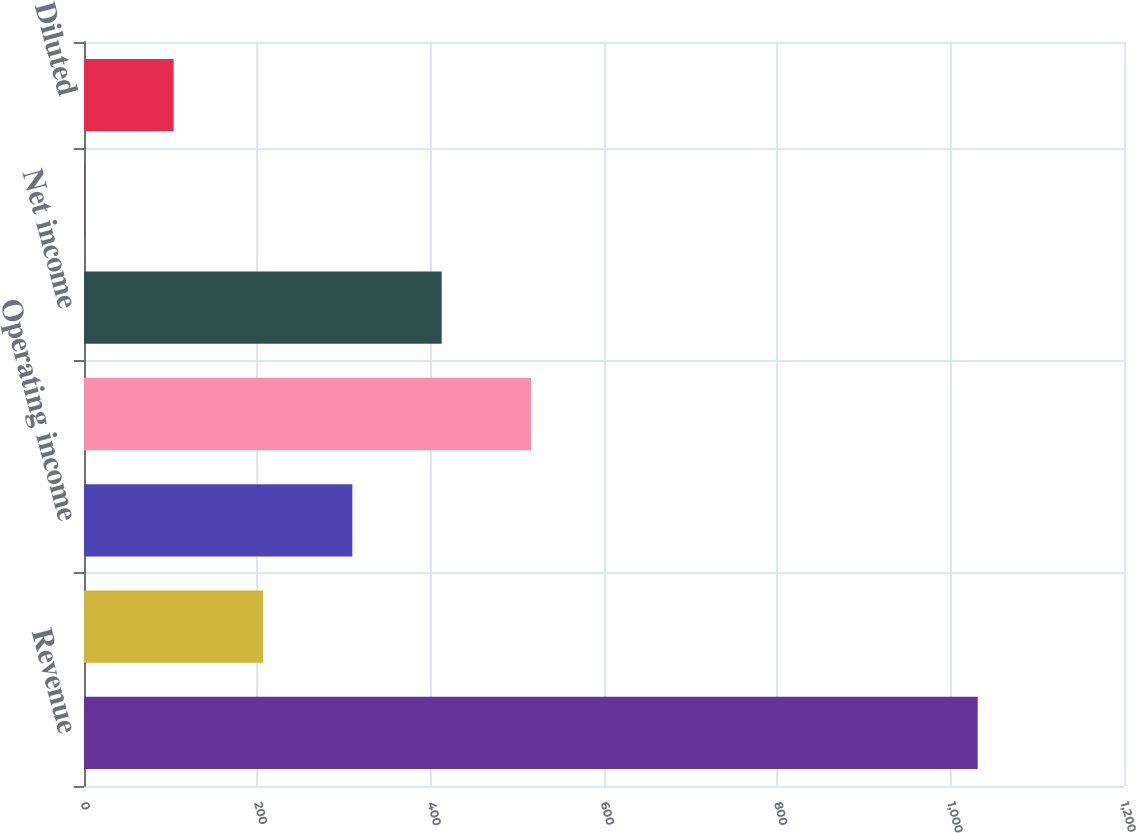Convert chart. <chart><loc_0><loc_0><loc_500><loc_500><bar_chart><fcel>Revenue<fcel>Operating income (a)<fcel>Operating income<fcel>Income before taxes<fcel>Net income<fcel>Basic<fcel>Diluted<nl><fcel>1031.2<fcel>206.53<fcel>309.62<fcel>515.79<fcel>412.71<fcel>0.35<fcel>103.44<nl></chart> 